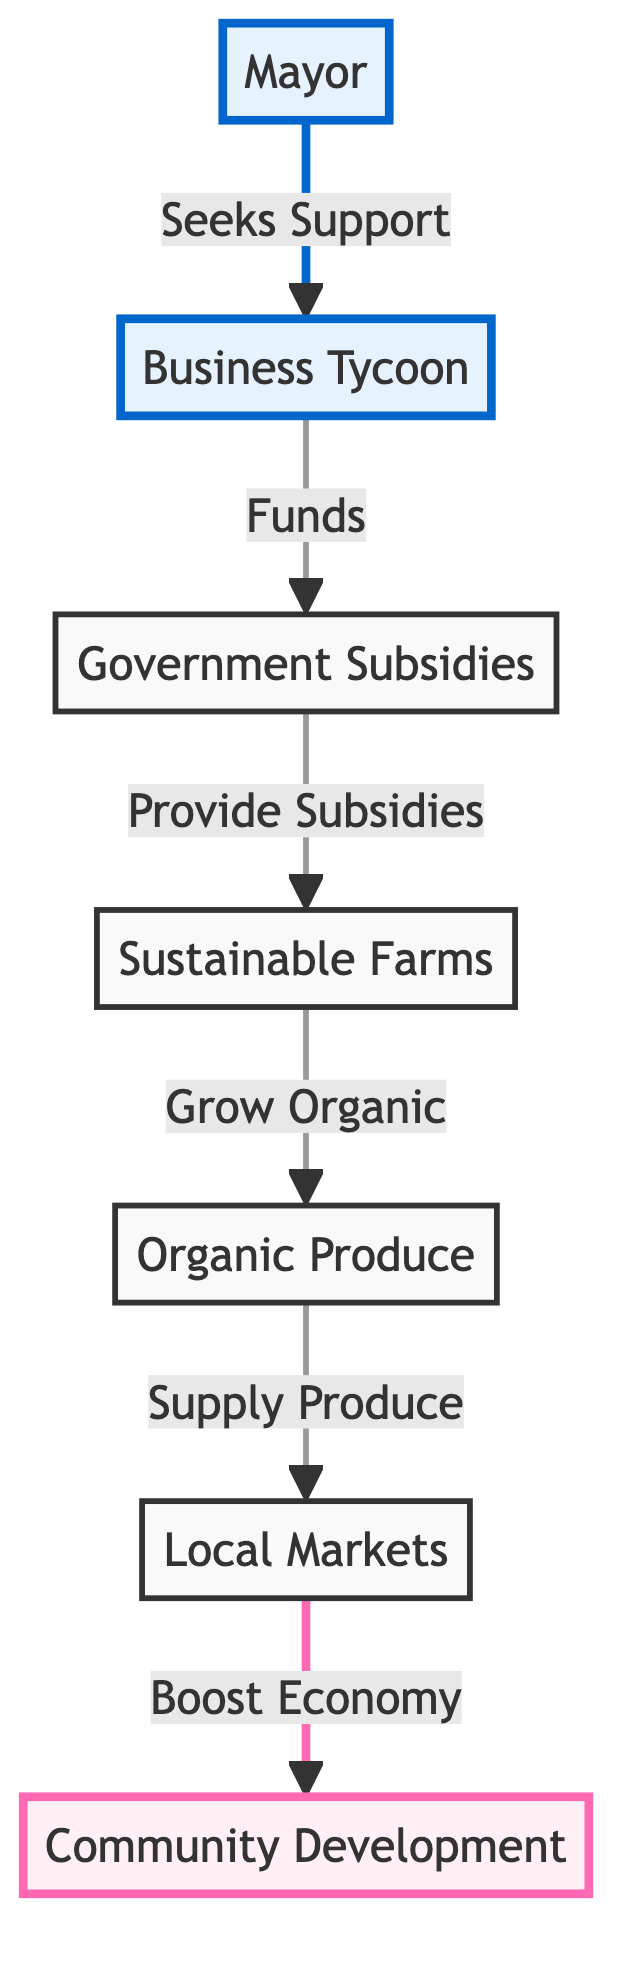What is the first step in the flow? The flow begins with the Mayor who seeks support from the Business Tycoon. This step is the starting point that initiates the whole process.
Answer: Mayor How many nodes are present in the diagram? By counting the labeled boxes in the diagram, we identify six distinct nodes: Mayor, Business Tycoon, Government Subsidies, Sustainable Farms, Organic Produce, and Local Markets.
Answer: Six What is the relationship between Government Subsidies and Sustainable Farms? The diagram indicates that the Government Subsidies provide subsidies to Sustainable Farms, illustrating a direct support mechanism for sustainable agriculture.
Answer: Provide Subsidies Which node is linked directly to Community Development? The Local Markets node is directly linked to the Community Development node, indicating that the economic boost from local markets contributes to community development.
Answer: Local Markets How do Sustainable Farms contribute to Organic Produce? Sustainable Farms grow organic products as part of their agricultural practices, establishing a direct link between the two nodes in the flow.
Answer: Grow Organic Which entities are highlighted in the diagram? The highlighted entities in the diagram are the Mayor and the Community Development, denoting their importance within the context of the flow and the visual emphasis.
Answer: Mayor, Community Development What financial role does the Business Tycoon play in the flow? The Business Tycoon provides funding that enables the allocation of government subsidies, highlighting a pivotal financial role in the broader process of supporting sustainable farming practices.
Answer: Funds What is the ultimate goal of the entire flow represented in the diagram? The ultimate goal of the flow is to achieve Community Development, which is the final outcome resulting from the boost to the economy created by the local markets.
Answer: Community Development Which node acts as an intermediary between Government Subsidies and the Local Markets? The Sustainable Farms node acts as an intermediary since it transforms the subsidies into organic produce that ultimately reaches the local markets.
Answer: Sustainable Farms 